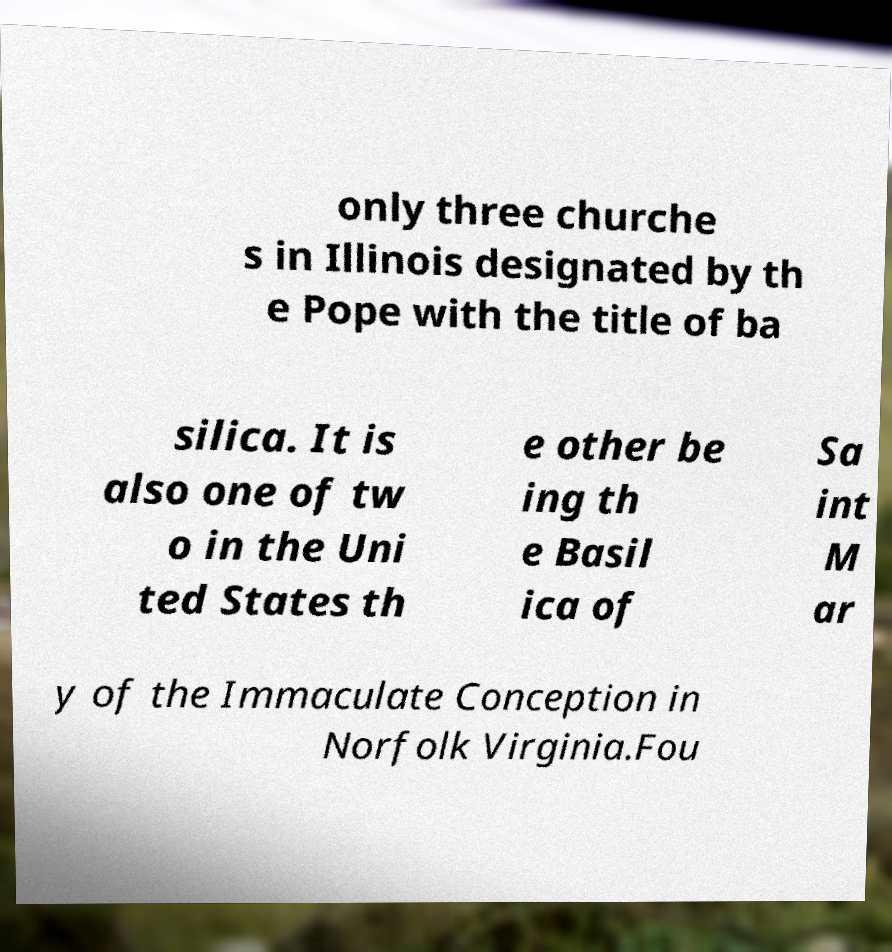I need the written content from this picture converted into text. Can you do that? only three churche s in Illinois designated by th e Pope with the title of ba silica. It is also one of tw o in the Uni ted States th e other be ing th e Basil ica of Sa int M ar y of the Immaculate Conception in Norfolk Virginia.Fou 